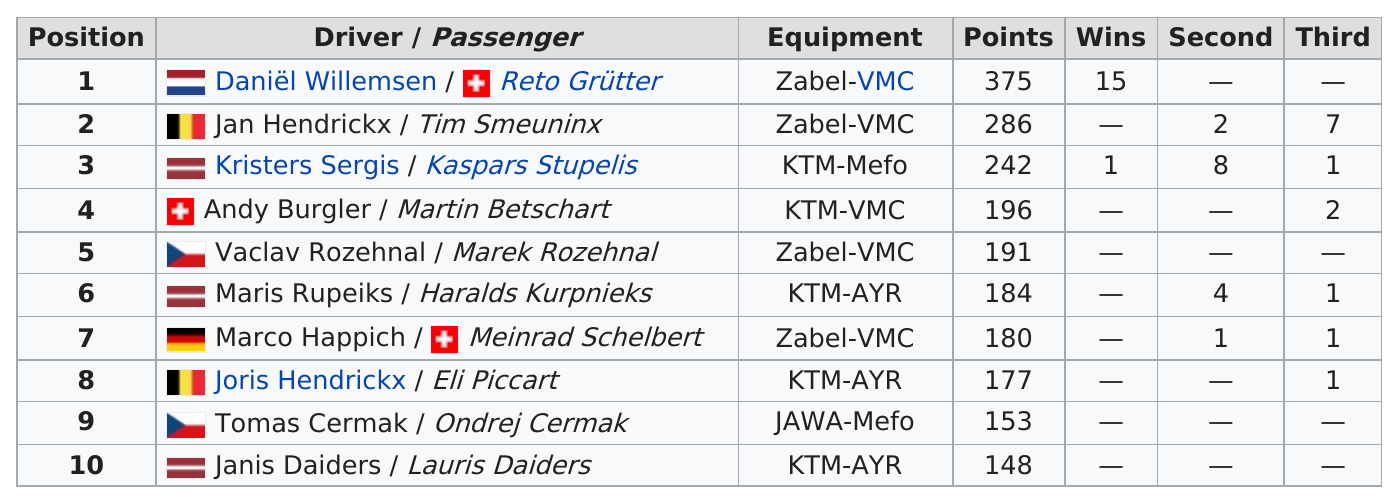Identify some key points in this picture. Daniel Willemsen scored 375 points with his passenger. Jan Hendrickx had more points than Marco Happich during the 2007 season by 106 points. The least number of points on the table is 148... Andy Burgler and his passenger, Martin Betschart, are traveling together. In the 2007 season, two drivers scored below 175 points. 